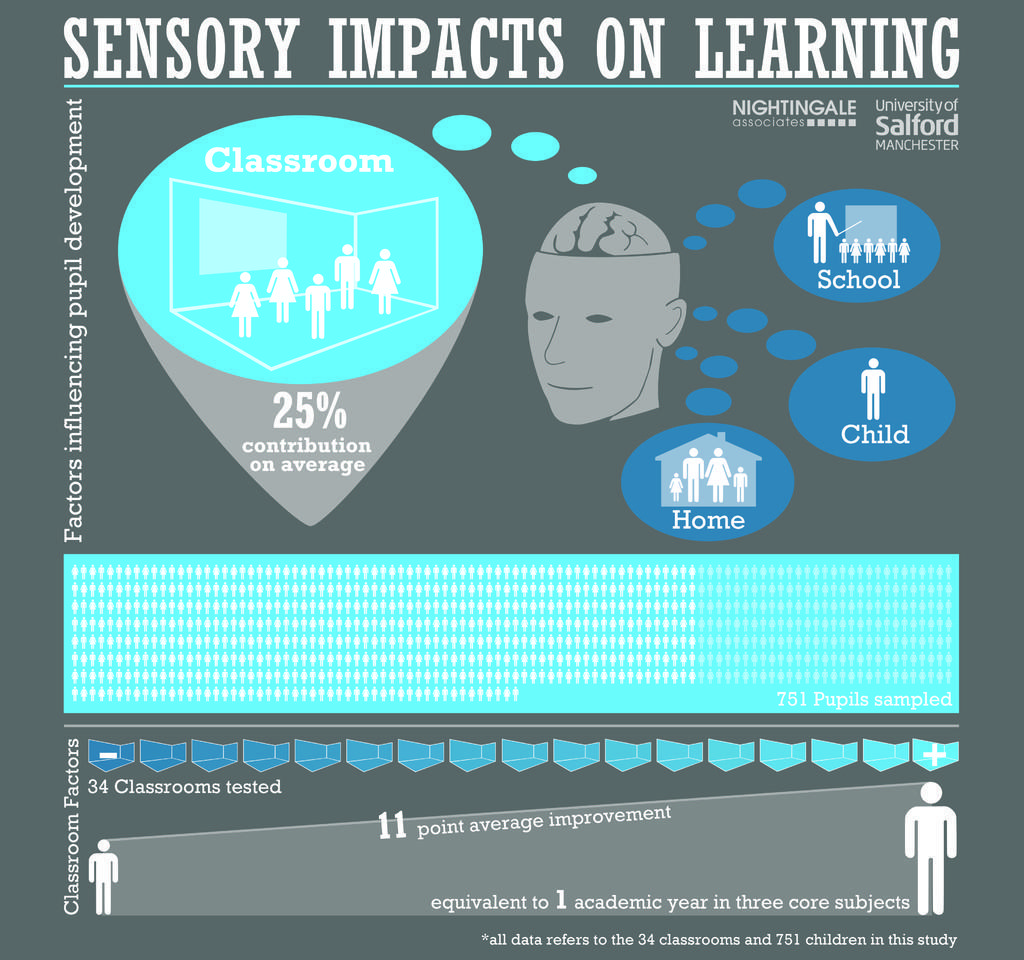Can you describe this image briefly? This is an edited image. In this image we can see some pictures and text on it. 